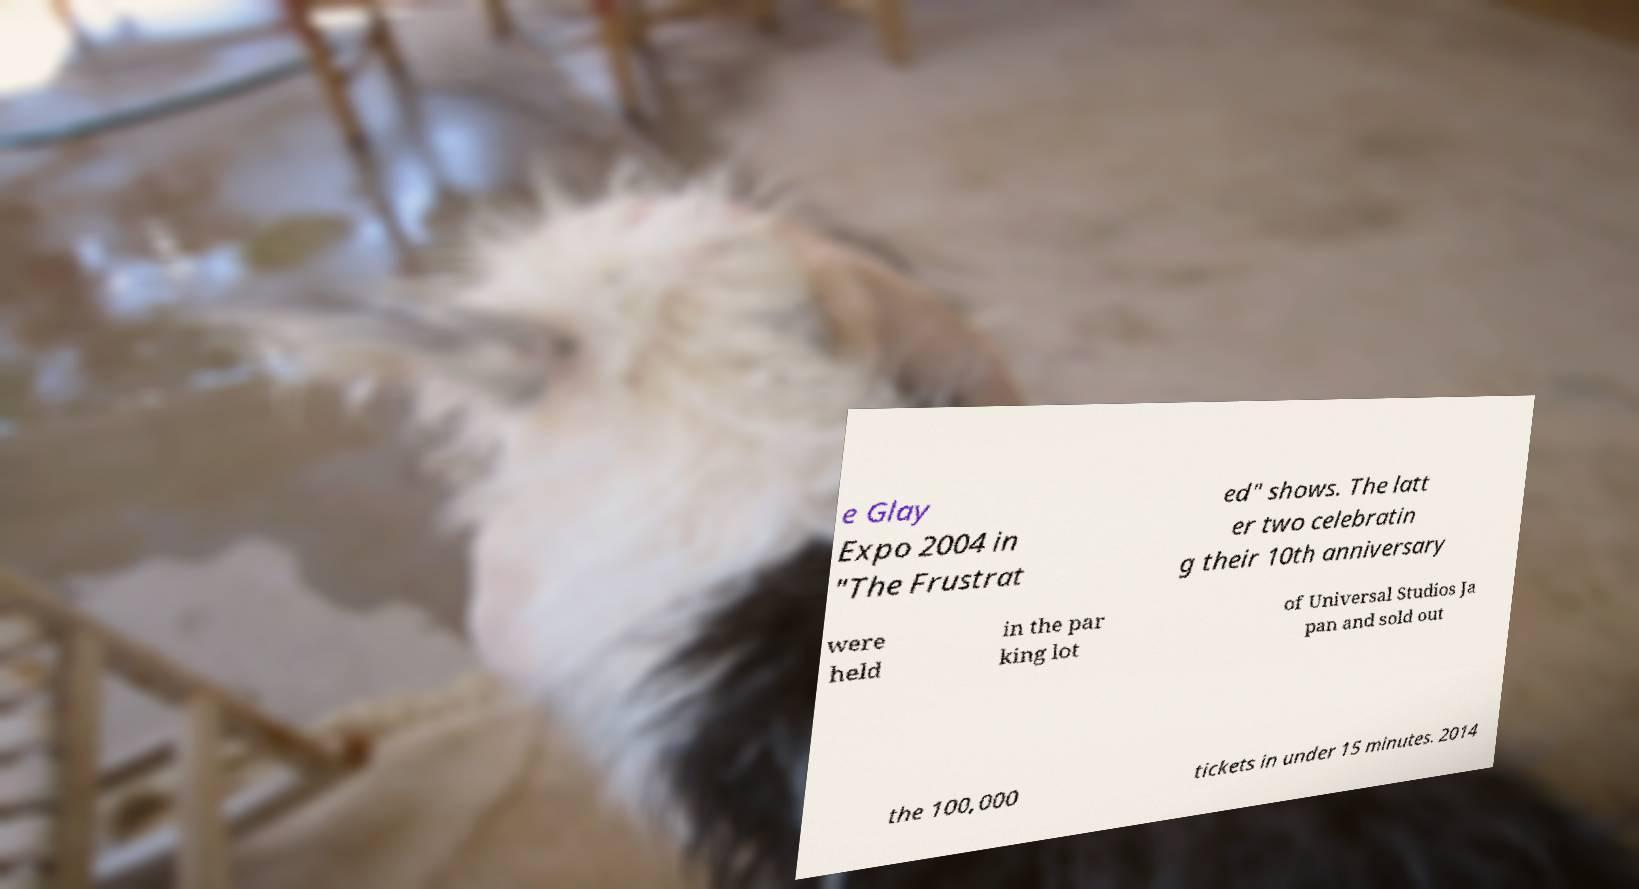Could you extract and type out the text from this image? e Glay Expo 2004 in "The Frustrat ed" shows. The latt er two celebratin g their 10th anniversary were held in the par king lot of Universal Studios Ja pan and sold out the 100,000 tickets in under 15 minutes. 2014 